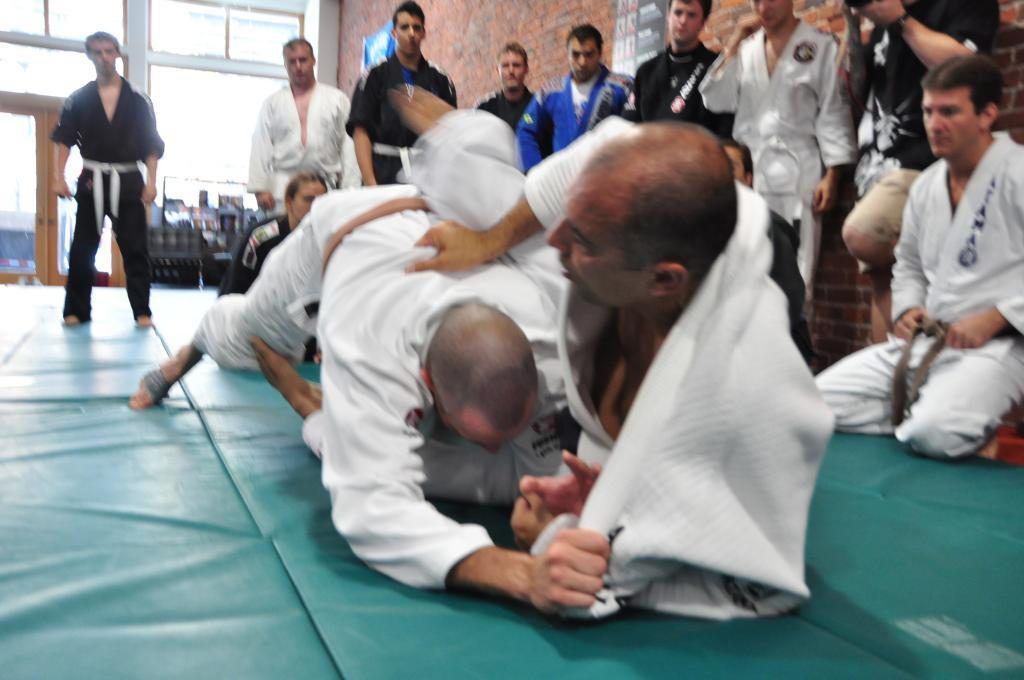How would you summarize this image in a sentence or two? In the picture we can see a floor with a green color mat on it, we can see two people are fighting and they are in a martial arts dresses and behind them, we can see some people are standing and watching them and they are also in a martial arts dresses and behind them we can see a wall and some part of the wall is glass and a glass door with a wooden frame. 